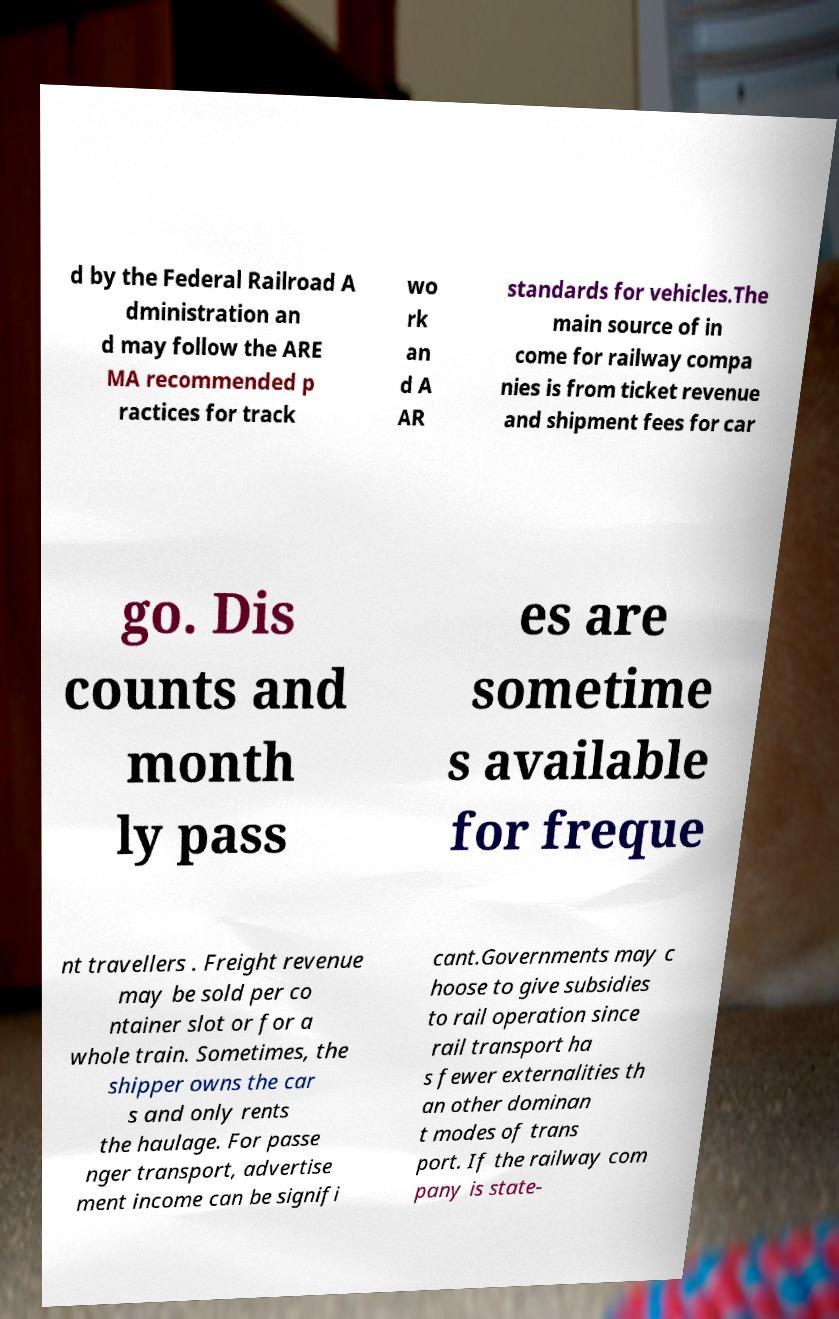Please read and relay the text visible in this image. What does it say? d by the Federal Railroad A dministration an d may follow the ARE MA recommended p ractices for track wo rk an d A AR standards for vehicles.The main source of in come for railway compa nies is from ticket revenue and shipment fees for car go. Dis counts and month ly pass es are sometime s available for freque nt travellers . Freight revenue may be sold per co ntainer slot or for a whole train. Sometimes, the shipper owns the car s and only rents the haulage. For passe nger transport, advertise ment income can be signifi cant.Governments may c hoose to give subsidies to rail operation since rail transport ha s fewer externalities th an other dominan t modes of trans port. If the railway com pany is state- 